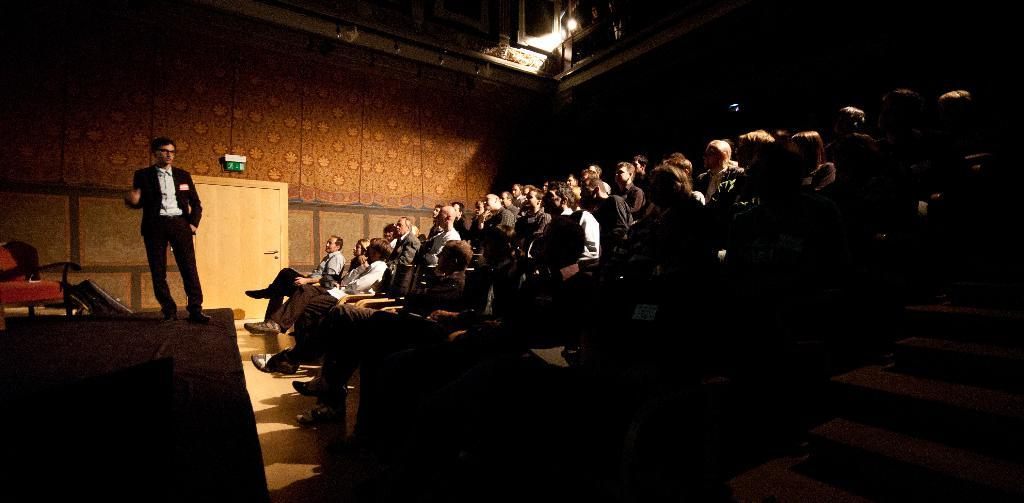What is the overall lighting condition in the image? The image is dark. What are the people in the image doing? The people are sitting on chairs in the image. Can you describe the man in the image? There is a man standing on a stage in the image. What type of furniture is visible in the image? Chairs are visible in the image. What can be seen in the background of the image? There is a wall, a door, and a board in the background of the image. What type of quartz is used to decorate the chairs in the image? There is no quartz present in the image, and the chairs are not decorated with any quartz. Can you tell me how many aunts are sitting in the chairs in the image? There is no mention of an aunt in the image, and we cannot determine the number of aunts based on the provided facts. 